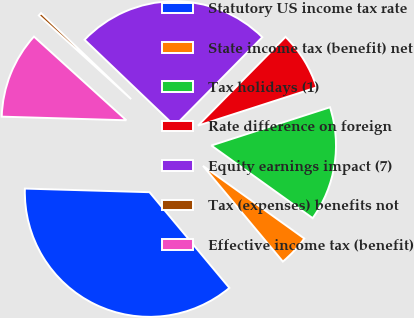Convert chart. <chart><loc_0><loc_0><loc_500><loc_500><pie_chart><fcel>Statutory US income tax rate<fcel>State income tax (benefit) net<fcel>Tax holidays (1)<fcel>Rate difference on foreign<fcel>Equity earnings impact (7)<fcel>Tax (expenses) benefits not<fcel>Effective income tax (benefit)<nl><fcel>36.53%<fcel>4.03%<fcel>14.86%<fcel>7.64%<fcel>25.26%<fcel>0.42%<fcel>11.25%<nl></chart> 